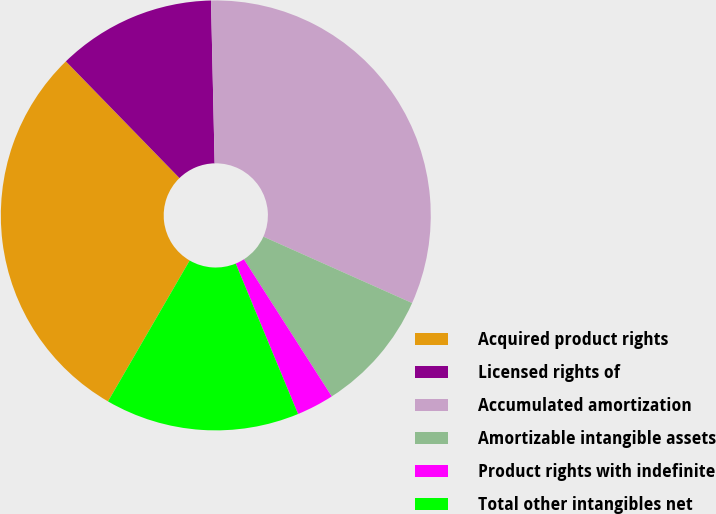Convert chart. <chart><loc_0><loc_0><loc_500><loc_500><pie_chart><fcel>Acquired product rights<fcel>Licensed rights of<fcel>Accumulated amortization<fcel>Amortizable intangible assets<fcel>Product rights with indefinite<fcel>Total other intangibles net<nl><fcel>29.36%<fcel>11.93%<fcel>32.04%<fcel>9.25%<fcel>2.82%<fcel>14.61%<nl></chart> 